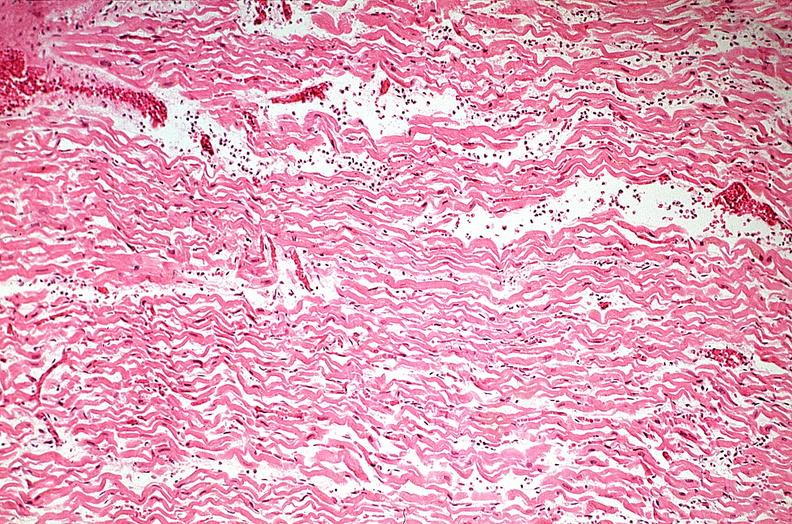what is present?
Answer the question using a single word or phrase. Cardiovascular 